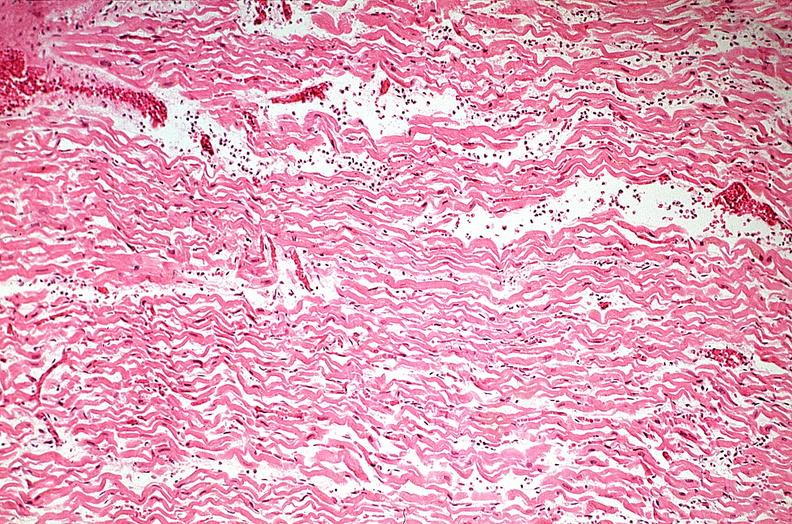what is present?
Answer the question using a single word or phrase. Cardiovascular 